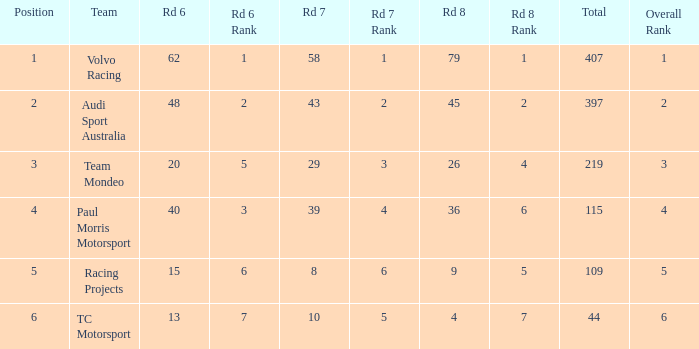What is the sum of total values for Rd 7 less than 8? None. 